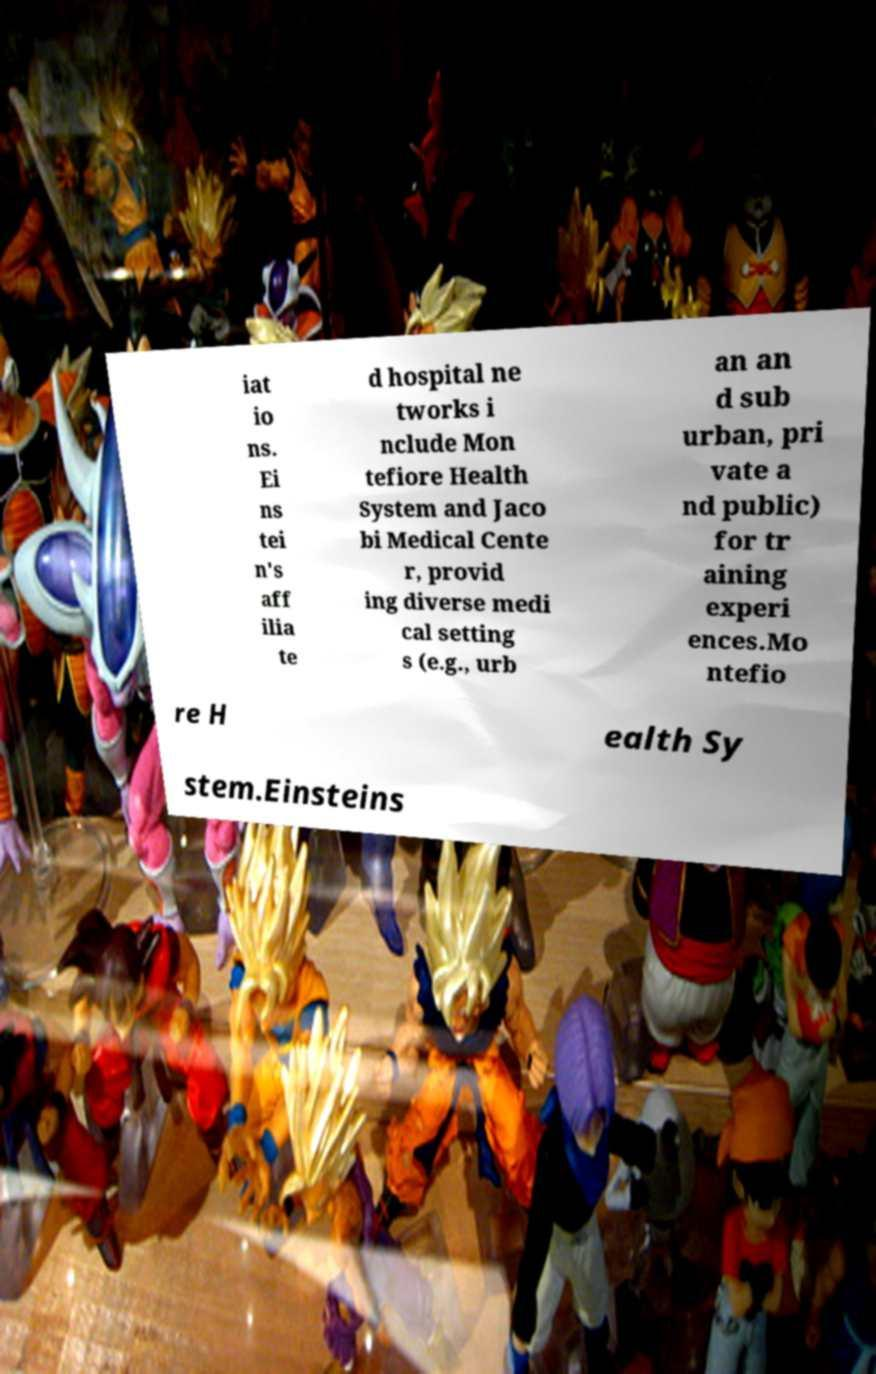Could you assist in decoding the text presented in this image and type it out clearly? iat io ns. Ei ns tei n's aff ilia te d hospital ne tworks i nclude Mon tefiore Health System and Jaco bi Medical Cente r, provid ing diverse medi cal setting s (e.g., urb an an d sub urban, pri vate a nd public) for tr aining experi ences.Mo ntefio re H ealth Sy stem.Einsteins 